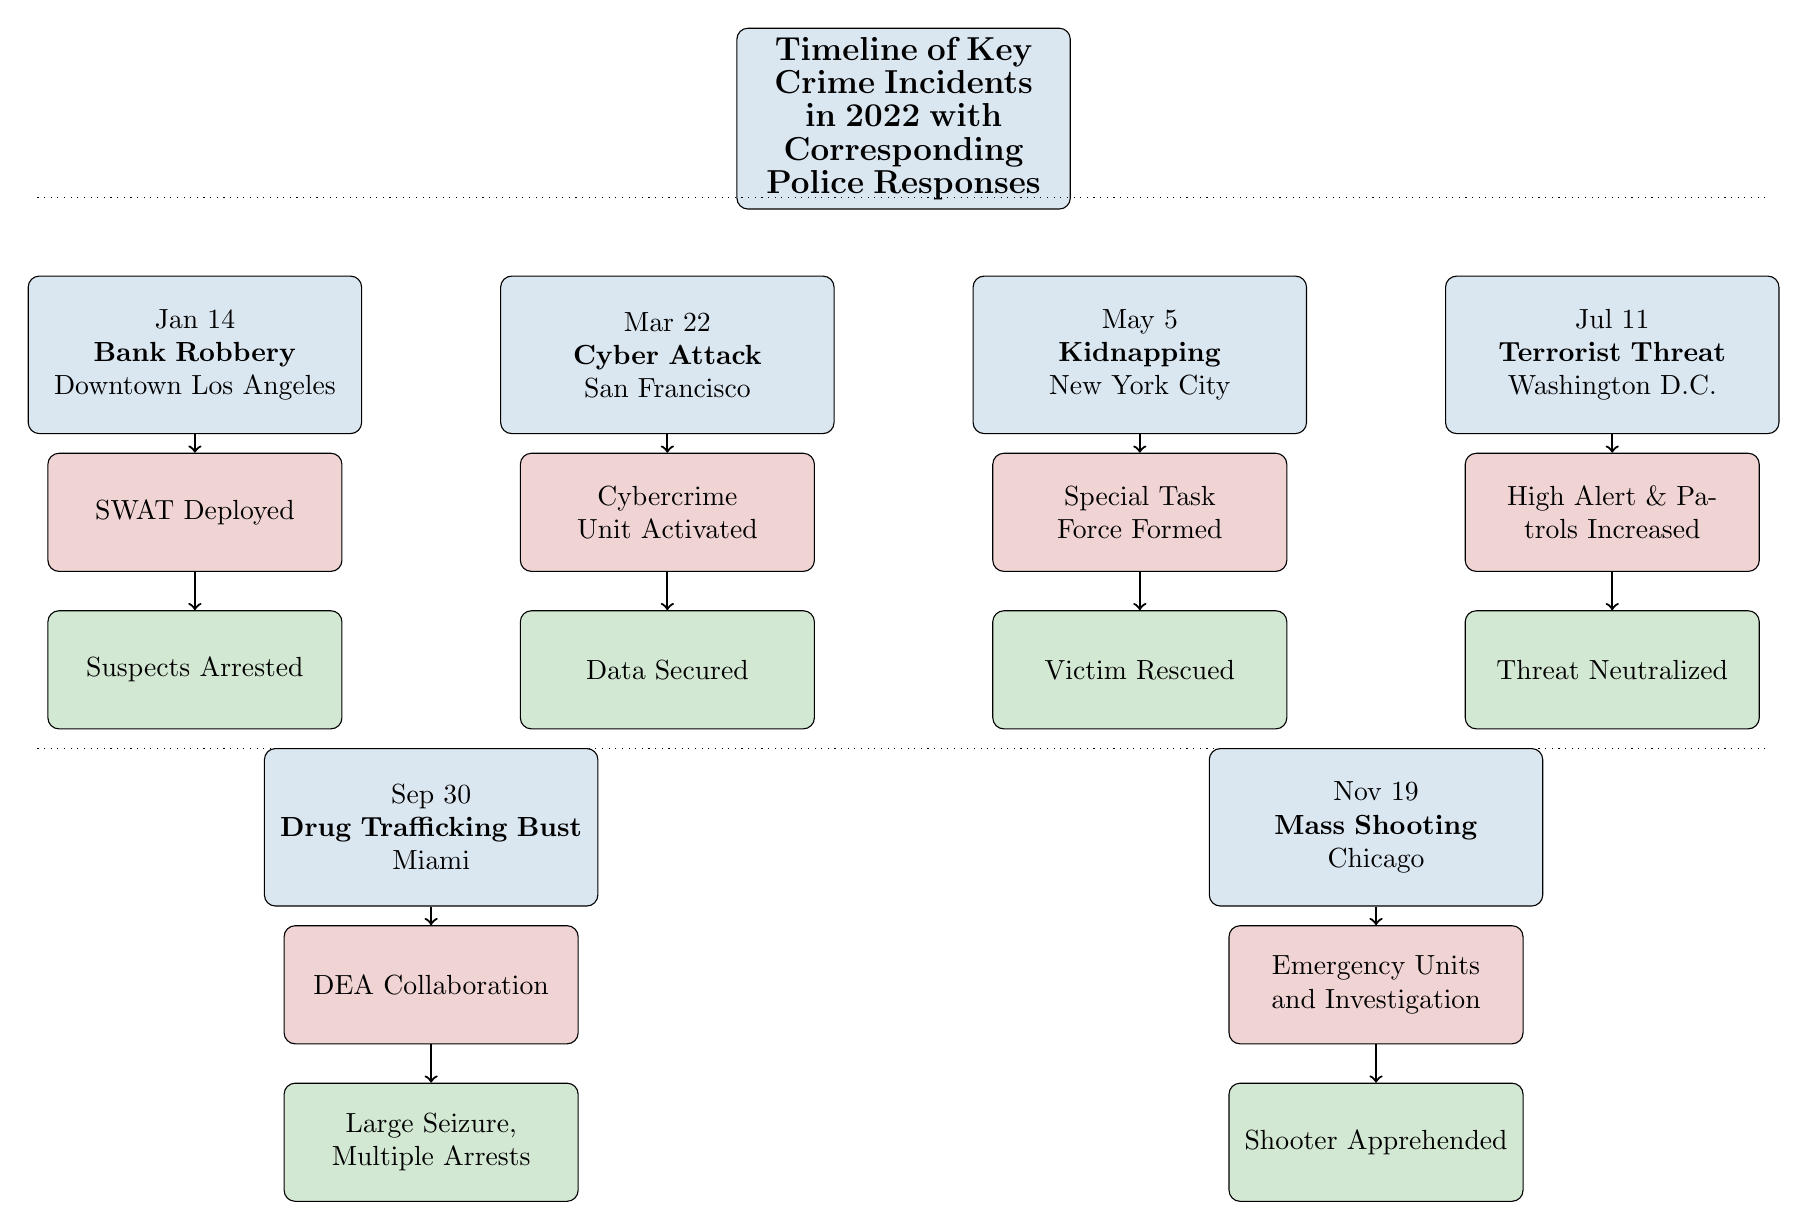What was the first crime incident in the timeline? The first crime incident listed is a bank robbery on January 14 in Downtown Los Angeles, as seen in the topmost section of the timeline.
Answer: Bank Robbery How many crime incidents are depicted in the diagram? By counting all the events listed in the diagram, we see six distinct crime incidents, represented by the event nodes.
Answer: 6 What police response was activated for the cyber attack? The corresponding police response for the cyber attack on March 22 is the activation of the Cybercrime Unit, as indicated next to the event node in the diagram.
Answer: Cybercrime Unit Activated What was the outcome of the mass shooting incident? The outcome of the mass shooting incident in Chicago was the apprehension of the shooter, as stated directly below the response node associated with this event.
Answer: Shooter Apprehended What was the police response to the terrorist threat? In response to the terrorist threat on July 11, the police increased patrols and went on high alert, which is explicitly mentioned in the response section of the diagram.
Answer: High Alert & Patrols Increased Which crime incident involved collaboration with the DEA? The crime incident that involved collaboration with the DEA occurred on September 30 and is labeled as a drug trafficking bust in Miami, as shown in the diagram.
Answer: Drug Trafficking Bust How does the response to the kidnapping compare to the response to the drug trafficking bust? The response to the kidnapping on May 5 forms a special task force, while the response to the drug trafficking bust involves collaboration with the DEA. This comparison shows that different strategies are used based on the nature of the crime.
Answer: Different strategies What police unit was formed for the kidnapping incident? The police unit formed for the kidnapping incident is a Special Task Force, as explicitly stated in the response section of the diagram directly under that event.
Answer: Special Task Force Formed What was the relationship between the bank robbery event and the suspects' arrest? The relationship between the bank robbery event on January 14 and the suspects' arrest is directional; the response of deploying SWAT leads to the arrest of suspects, establishing a direct link shown through arrows in the flow of the diagram.
Answer: SWAT leads to arrest 